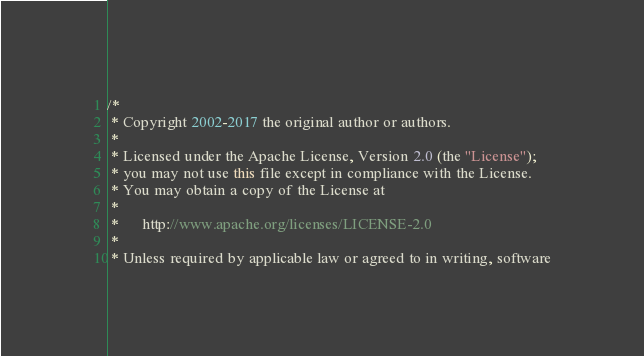<code> <loc_0><loc_0><loc_500><loc_500><_Java_>/*
 * Copyright 2002-2017 the original author or authors.
 *
 * Licensed under the Apache License, Version 2.0 (the "License");
 * you may not use this file except in compliance with the License.
 * You may obtain a copy of the License at
 *
 *      http://www.apache.org/licenses/LICENSE-2.0
 *
 * Unless required by applicable law or agreed to in writing, software</code> 